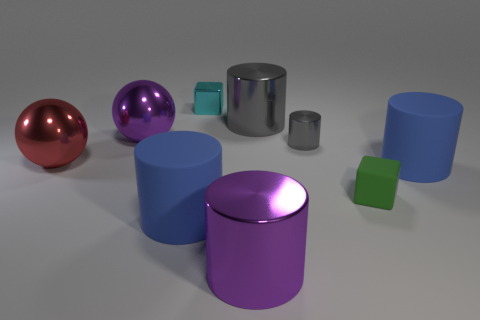Subtract all purple cubes. How many blue cylinders are left? 2 Subtract all matte cylinders. How many cylinders are left? 3 Subtract all purple cylinders. How many cylinders are left? 4 Add 1 small blue things. How many objects exist? 10 Subtract all cylinders. How many objects are left? 4 Subtract all brown cylinders. Subtract all purple cubes. How many cylinders are left? 5 Add 2 big metallic balls. How many big metallic balls are left? 4 Add 9 large gray blocks. How many large gray blocks exist? 9 Subtract 1 purple cylinders. How many objects are left? 8 Subtract all brown shiny spheres. Subtract all cyan metallic objects. How many objects are left? 8 